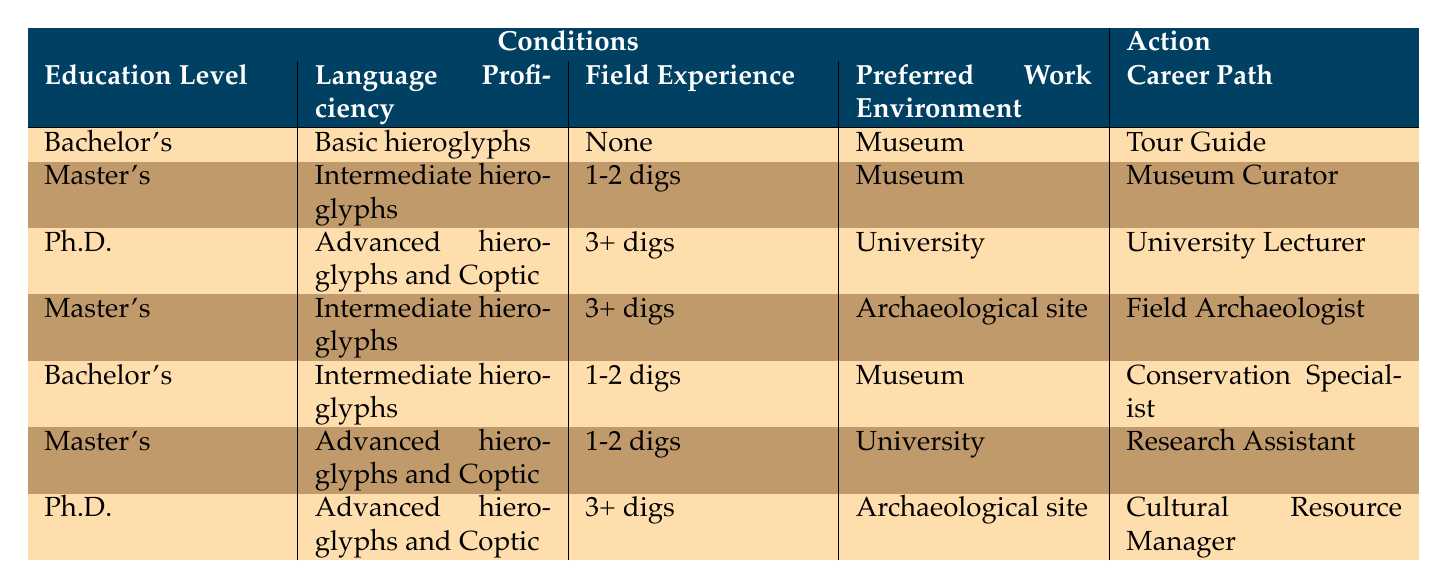What is the career path for someone with a Bachelor's degree, Basic hieroglyphs, no field experience, and a preference for a Museum? According to the table, this combination corresponds to the role of a Tour Guide.
Answer: Tour Guide What career can a Master’s degree holder with Intermediate hieroglyphs skills and 1-2 digs of field experience pursue in a Museum? The table indicates that this profile aligns with the career path of a Museum Curator.
Answer: Museum Curator Is it possible to become a University Lecturer without a Ph.D.? The table shows that only the combination of a Ph.D., Advanced hieroglyphs and Coptic, 3+ digs, and a University work environment leads to this position, indicating that a Ph.D. is essential.
Answer: No What career paths require Advanced hieroglyphs and Coptic proficiency? The table reveals that two career paths require this expertise: University Lecturer and Cultural Resource Manager. These correspond to a Ph.D. with 3+ digs in a University setting and a Ph.D. with 3+ digs in an Archaeological site, respectively.
Answer: University Lecturer and Cultural Resource Manager If someone has a Master's degree and 3+ digs of experience, which careers are available to them? The table indicates that these individuals can either become a Field Archaeologist if they also have Intermediate hieroglyphs and prefer an Archaeological site, or a Research Assistant with Advanced hieroglyphs and Coptic in a University. Therefore, there are two possible career paths.
Answer: Field Archaeologist or Research Assistant How many career paths can someone pursue if they have a Bachelor's degree, Intermediate hieroglyphs, 1-2 digs, and prefer working in a Museum? The table specifies that this combination leads to just one career path, which is Conservation Specialist.
Answer: 1 Is being a Field Archaeologist an option for someone with a Master's degree, Basic hieroglyphs, and 1-2 digs of experience? The table states that a Master’s degree combined with Basic hieroglyphs does not correlate with the Field Archaeologist position, which requires Intermediate hieroglyphs and 3+ digs. Hence, this combination would not qualify for that career.
Answer: No Which action is associated with a Ph.D. holder who has 3+ digs and prefers working on an Archaeological site? Referring to the table, the action associated with this profile is to become a Cultural Resource Manager.
Answer: Cultural Resource Manager 